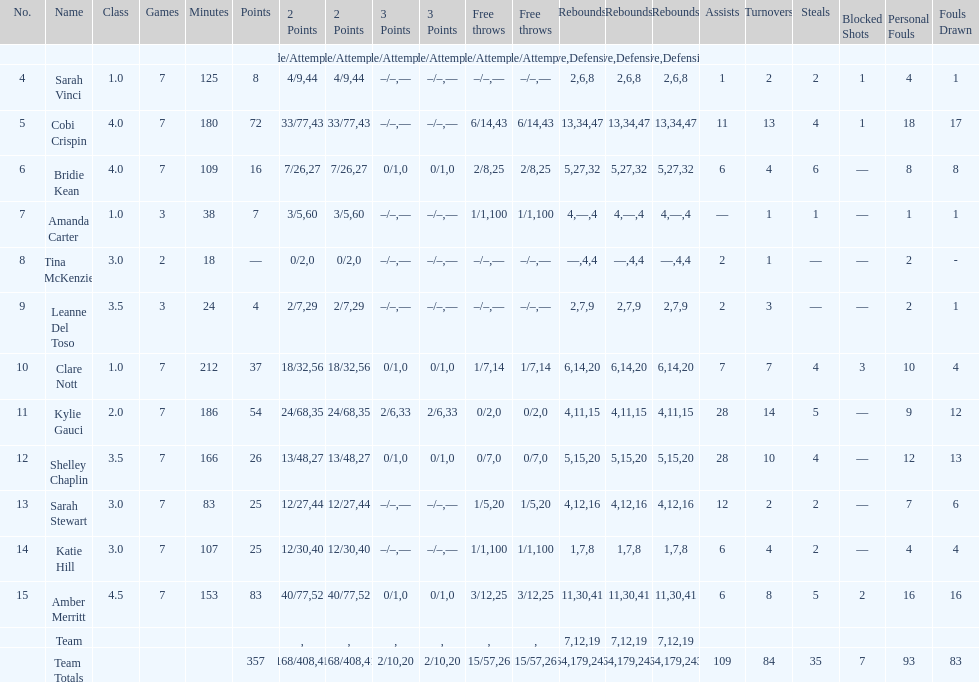Next to merritt, who was the top scorer? Cobi Crispin. 